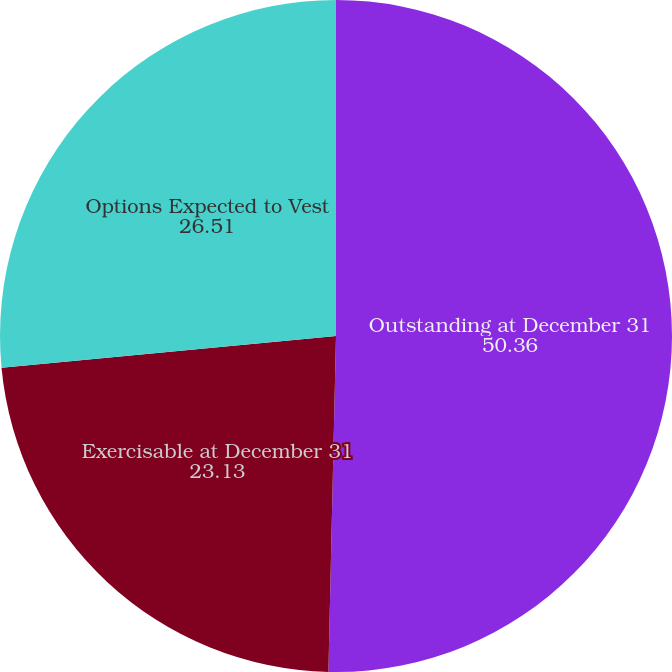Convert chart to OTSL. <chart><loc_0><loc_0><loc_500><loc_500><pie_chart><fcel>Outstanding at December 31<fcel>Exercisable at December 31<fcel>Options Expected to Vest<nl><fcel>50.36%<fcel>23.13%<fcel>26.51%<nl></chart> 